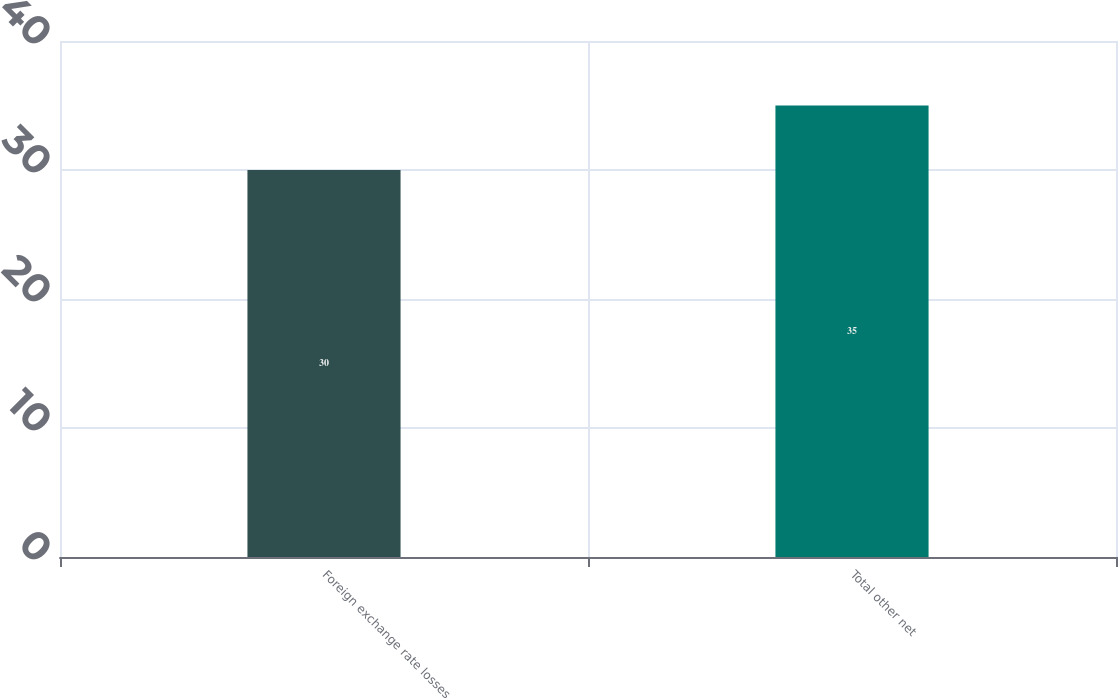Convert chart. <chart><loc_0><loc_0><loc_500><loc_500><bar_chart><fcel>Foreign exchange rate losses<fcel>Total other net<nl><fcel>30<fcel>35<nl></chart> 